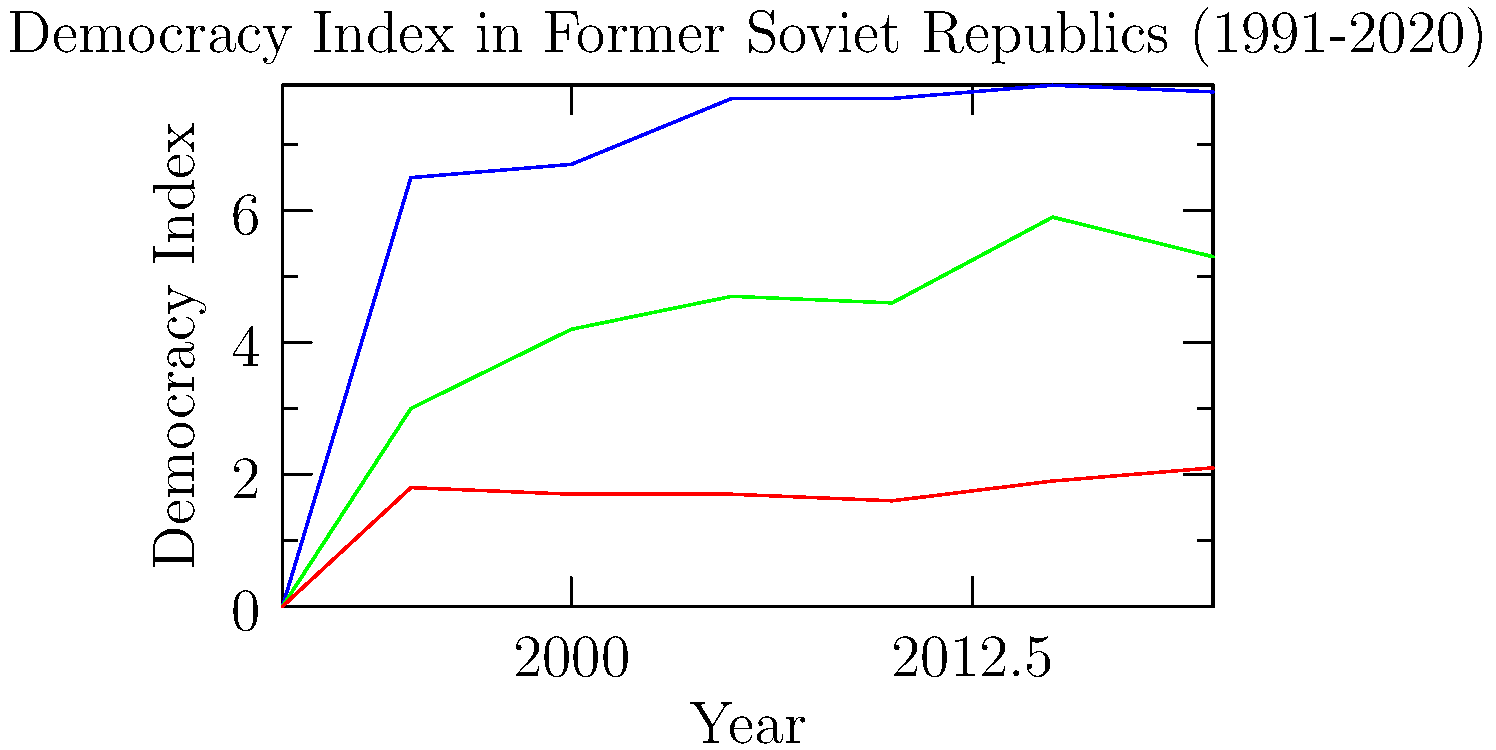Analyzing the graph of democracy indices for Estonia, Georgia, and Uzbekistan from 1991 to 2020, which country shows the most consistent upward trend in its democratic development, and how does this relate to Alexander Cooley's research on post-Soviet states? To answer this question, we need to follow these steps:

1. Examine the trends for each country:
   a) Estonia: Starts at 0 in 1991, rapidly increases to 6.5 by 1995, and then shows a steady upward trend reaching 7.8 by 2020.
   b) Georgia: Starts at 0 in 1991, increases to 3.0 by 1995, and shows an overall upward trend with some fluctuations, reaching 5.3 by 2020.
   c) Uzbekistan: Starts at 0 in 1991, increases slightly to 1.8 by 1995, and then remains relatively stagnant, hovering around 2.0 throughout the period.

2. Identify the most consistent upward trend:
   Estonia shows the most consistent upward trend, with a sharp initial increase followed by steady improvements over time.

3. Relate this to Alexander Cooley's research:
   Cooley's work focuses on the varying trajectories of post-Soviet states and the factors influencing their democratic development. Estonia's consistent progress aligns with Cooley's observations about the Baltic states' successful democratic transitions, often attributed to factors such as:
   a) Strong civil society
   b) Rapid economic reforms
   c) Integration with Western institutions (EU and NATO)
   d) Effective state-building processes

4. Consider the contrasts:
   The graph illustrates the divergent paths of post-Soviet states that Cooley often discusses. While Estonia shows consistent democratic progress, Georgia displays a more volatile trajectory, and Uzbekistan demonstrates the challenges of authoritarian persistence in Central Asia.

5. Reflect on the implications:
   This graph supports Cooley's arguments about the importance of both domestic factors and international engagement in shaping democratic outcomes in post-Soviet spaces.
Answer: Estonia shows the most consistent upward trend, aligning with Cooley's research on successful post-Soviet democratic transitions in Baltic states due to strong civil society, economic reforms, and Western integration. 